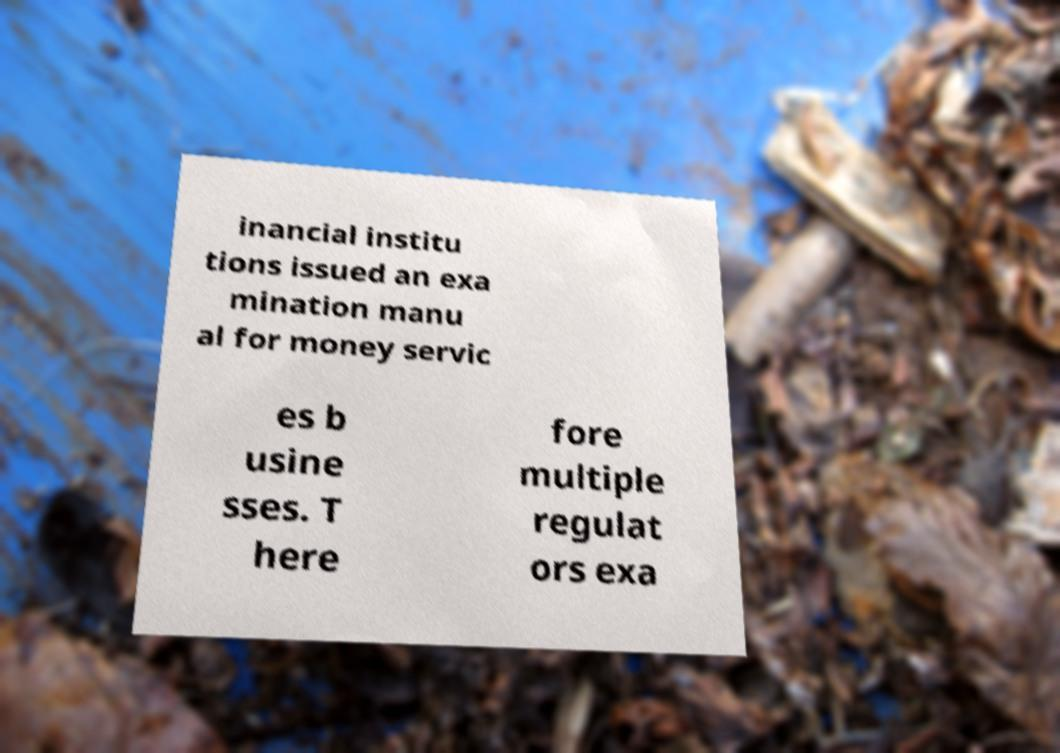Please read and relay the text visible in this image. What does it say? inancial institu tions issued an exa mination manu al for money servic es b usine sses. T here fore multiple regulat ors exa 